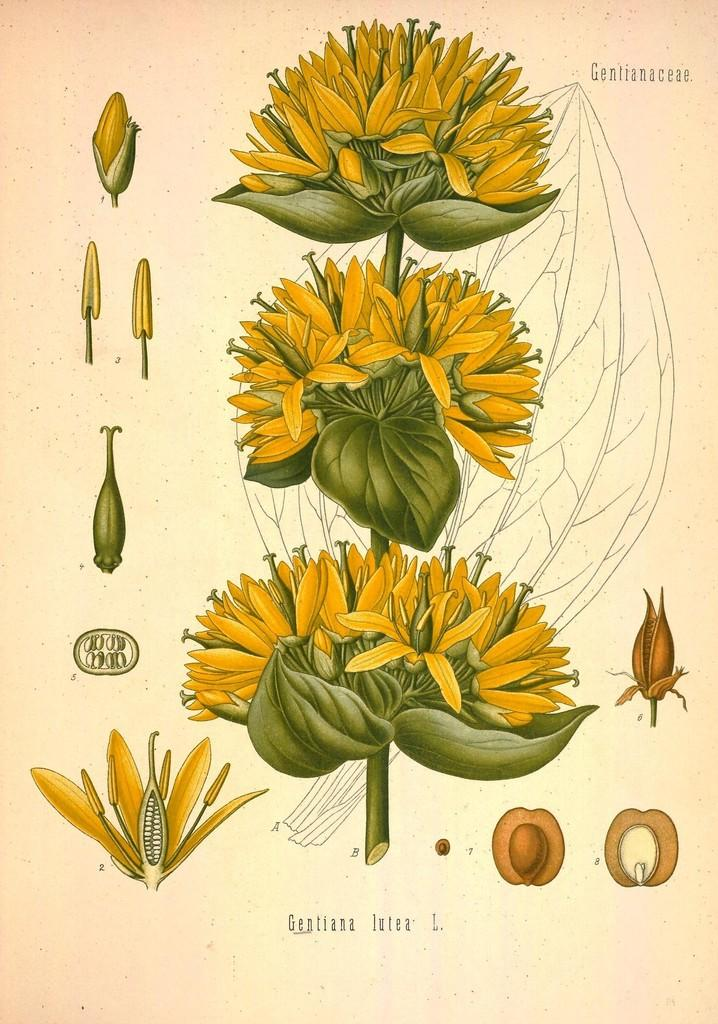What is depicted in the image? There is a drawing of flowers in the image. What is the medium of the drawing? The drawing is on a piece of paper. What type of hobbies does the brother have in the image? There is no reference to a brother or any hobbies in the image; it only features a drawing of flowers on a piece of paper. 